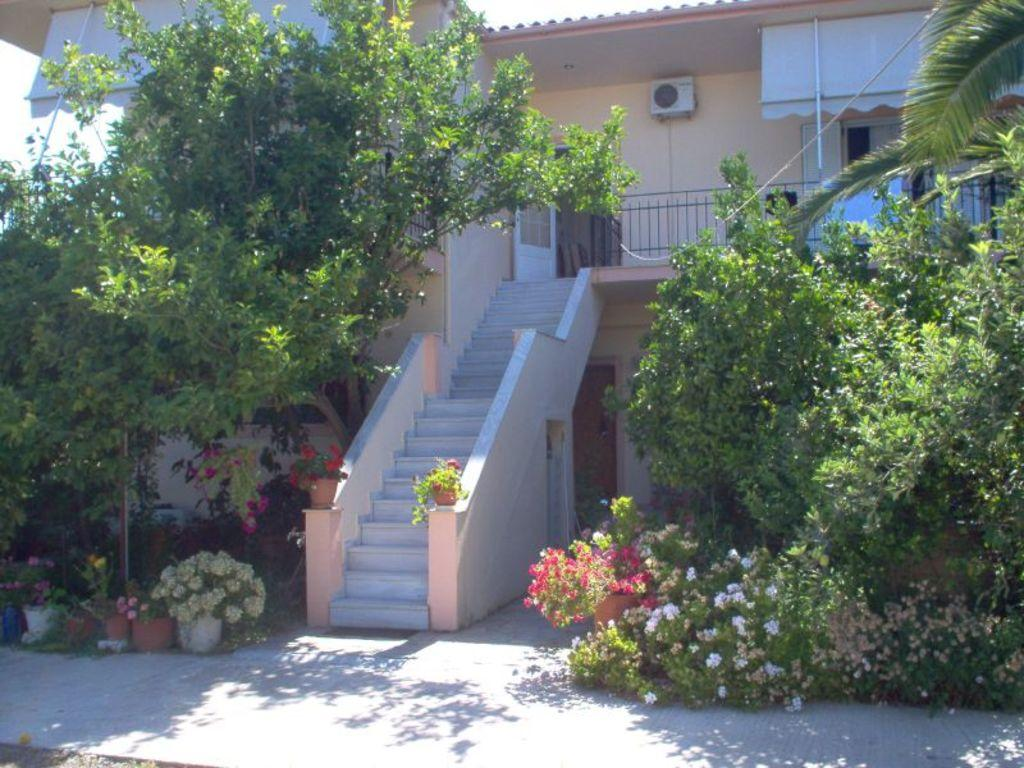What type of plants can be seen in the image? There are plants with flowers in the image. What other natural elements are present in the image? There are trees in the image. Can you describe any architectural features in the image? There are steps, a railing, a building, a door, and windows in the image. What additional objects can be seen in the image? There are poles and an AC unit on the wall in the image. What part of the natural environment is visible in the image? The sky is visible in the image. What type of leather is being used to hold the bath in place in the image? There is no bath present in the image, and therefore no leather or any related materials can be observed. 